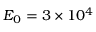Convert formula to latex. <formula><loc_0><loc_0><loc_500><loc_500>{ E } _ { 0 } = 3 \times 1 0 ^ { 4 }</formula> 